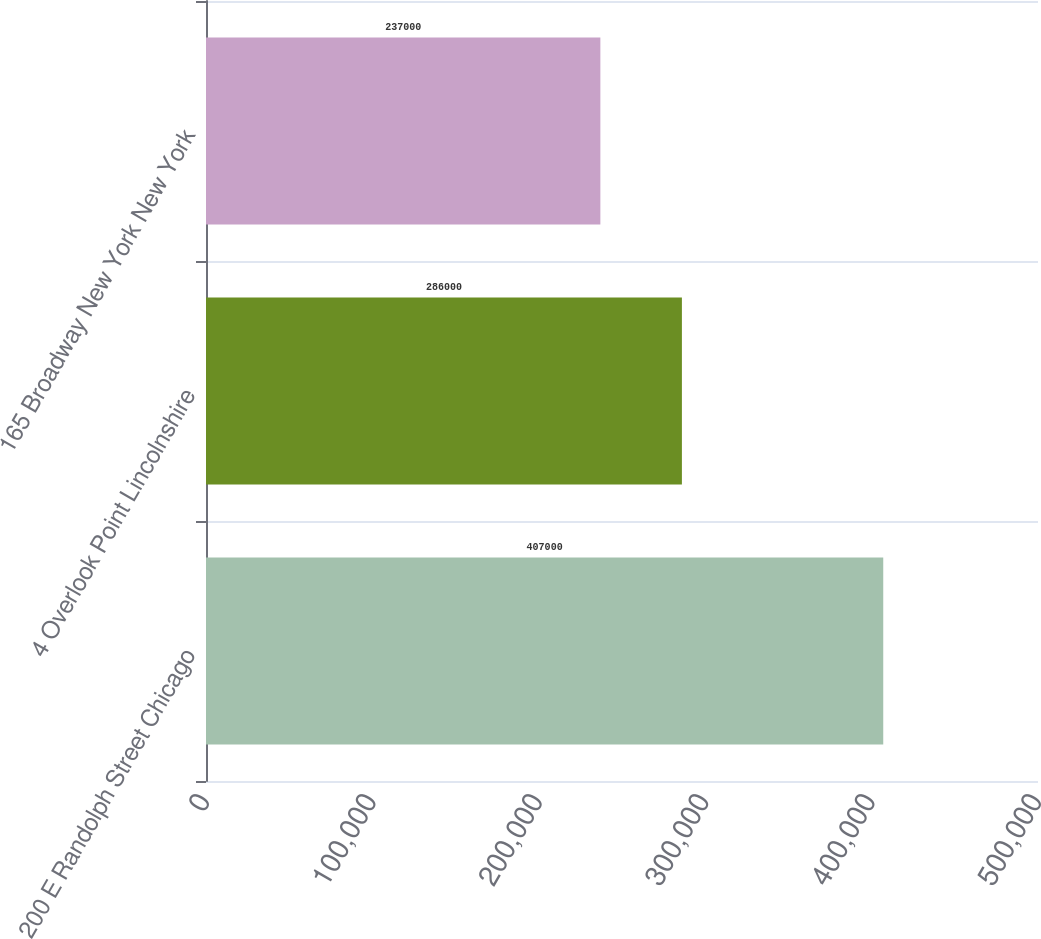<chart> <loc_0><loc_0><loc_500><loc_500><bar_chart><fcel>200 E Randolph Street Chicago<fcel>4 Overlook Point Lincolnshire<fcel>165 Broadway New York New York<nl><fcel>407000<fcel>286000<fcel>237000<nl></chart> 